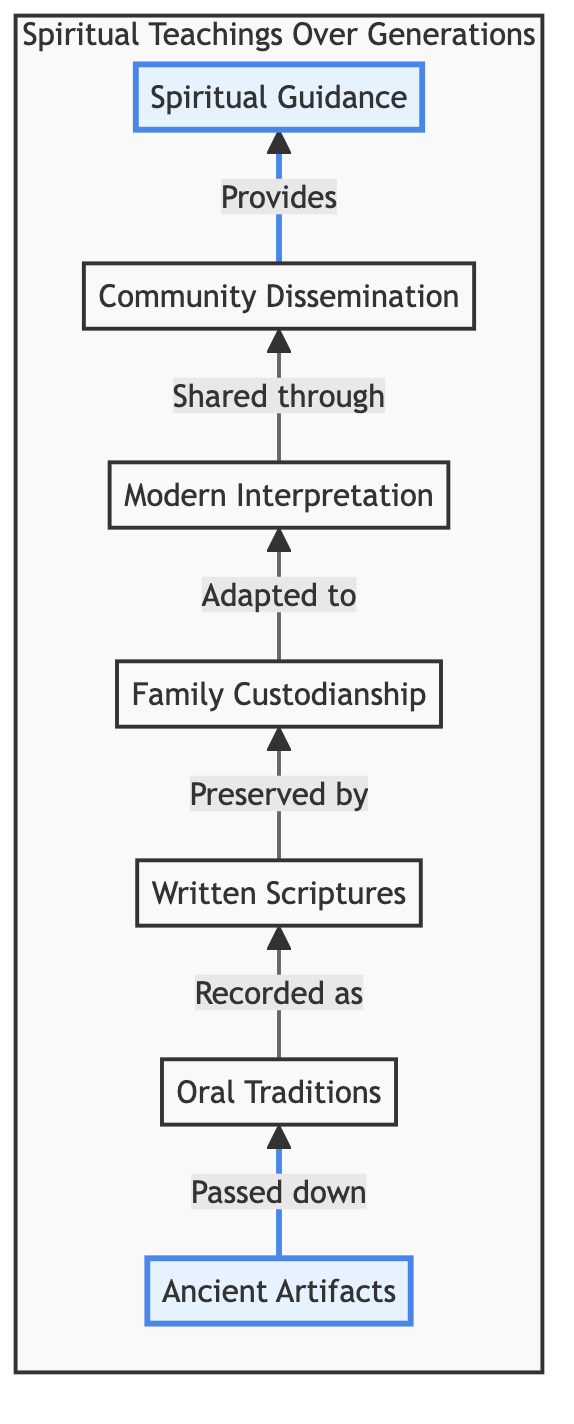What is the first element in the flow chart? The first element in the flow chart is located at the bottom position, which is "Ancient Artifacts."
Answer: Ancient Artifacts How many total elements are there in the diagram? Counting each node from bottom to top, there are seven elements in the diagram: Ancient Artifacts, Oral Traditions, Written Scriptures, Family Custodianship, Modern Interpretation, Community Dissemination, and Spiritual Guidance.
Answer: 7 What connects "Family Custodianship" to "Modern Interpretation"? The connection between "Family Custodianship" and "Modern Interpretation" is represented by an arrow that indicates the flow towards adapting the preserved teachings to contemporary contexts.
Answer: Adapted to Which node is the last in the flow? The last node at the top of the flow chart is "Spiritual Guidance." This indicates the culmination of teachings being imparted for the benefit of current and future generations.
Answer: Spiritual Guidance Which element immediately precedes "Spiritual Guidance"? The element that comes directly before "Spiritual Guidance" in the flow chart is "Community Dissemination," indicating that teachings are shared within the community before providing guidance.
Answer: Community Dissemination What does "Oral Traditions" lead to? "Oral Traditions" leads to the next node, which is "Written Scriptures." This signifies that stories and teachings passed down verbally are recorded in written form.
Answer: Written Scriptures What is described as the responsibility of family members in the chart? The responsibility of family members to protect and teach these teachings and artifacts is described under the node "Family Custodianship."
Answer: Family Custodianship How is ancient wisdom communicated according to the diagram? Ancient wisdom is communicated through multiple steps, ultimately culminating in "Spiritual Guidance," which provides wisdom and direction based on inherited knowledge.
Answer: Spiritual Guidance What is the flow direction of the chart? The flow direction of the chart is indicated by arrows pointing upwards, demonstrating a progression from ancient artifacts to spiritual guidance and teachings.
Answer: Upwards 